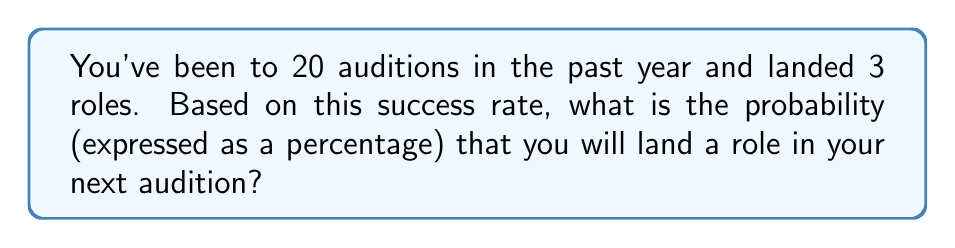Show me your answer to this math problem. To solve this problem, we need to calculate the probability based on past events. Here's how we can approach it:

1. First, let's identify the important information:
   - Total number of auditions: 20
   - Number of roles landed: 3

2. The probability of an event is calculated by dividing the number of favorable outcomes by the total number of possible outcomes:

   $$P(\text{event}) = \frac{\text{number of favorable outcomes}}{\text{total number of possible outcomes}}$$

3. In this case:
   - Favorable outcomes = number of roles landed = 3
   - Total possible outcomes = total number of auditions = 20

4. Let's plug these numbers into our probability formula:

   $$P(\text{landing a role}) = \frac{3}{20} = 0.15$$

5. To express this as a percentage, we multiply by 100:

   $$0.15 \times 100 = 15\%$$

Therefore, based on your past audition success rate, there is a 15% probability that you will land a role in your next audition.
Answer: 15% 